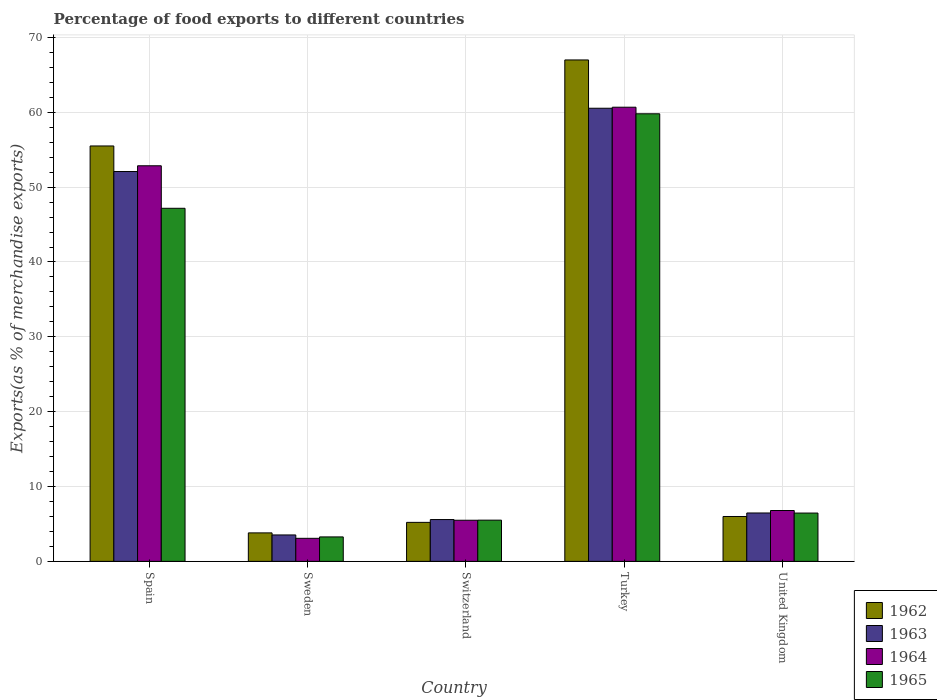How many groups of bars are there?
Your response must be concise. 5. Are the number of bars per tick equal to the number of legend labels?
Ensure brevity in your answer.  Yes. Are the number of bars on each tick of the X-axis equal?
Provide a succinct answer. Yes. How many bars are there on the 1st tick from the left?
Provide a short and direct response. 4. What is the label of the 4th group of bars from the left?
Your answer should be compact. Turkey. In how many cases, is the number of bars for a given country not equal to the number of legend labels?
Your answer should be compact. 0. What is the percentage of exports to different countries in 1963 in Sweden?
Provide a succinct answer. 3.53. Across all countries, what is the maximum percentage of exports to different countries in 1964?
Your response must be concise. 60.68. Across all countries, what is the minimum percentage of exports to different countries in 1963?
Offer a terse response. 3.53. In which country was the percentage of exports to different countries in 1964 maximum?
Make the answer very short. Turkey. In which country was the percentage of exports to different countries in 1965 minimum?
Your response must be concise. Sweden. What is the total percentage of exports to different countries in 1963 in the graph?
Offer a very short reply. 128.21. What is the difference between the percentage of exports to different countries in 1965 in Spain and that in Sweden?
Give a very brief answer. 43.9. What is the difference between the percentage of exports to different countries in 1963 in Turkey and the percentage of exports to different countries in 1962 in Spain?
Your answer should be compact. 5.04. What is the average percentage of exports to different countries in 1962 per country?
Keep it short and to the point. 27.5. What is the difference between the percentage of exports to different countries of/in 1963 and percentage of exports to different countries of/in 1964 in Spain?
Give a very brief answer. -0.77. In how many countries, is the percentage of exports to different countries in 1965 greater than 34 %?
Offer a terse response. 2. What is the ratio of the percentage of exports to different countries in 1964 in Sweden to that in United Kingdom?
Keep it short and to the point. 0.45. Is the percentage of exports to different countries in 1964 in Sweden less than that in Turkey?
Your answer should be compact. Yes. Is the difference between the percentage of exports to different countries in 1963 in Sweden and Switzerland greater than the difference between the percentage of exports to different countries in 1964 in Sweden and Switzerland?
Your response must be concise. Yes. What is the difference between the highest and the second highest percentage of exports to different countries in 1964?
Offer a terse response. 7.83. What is the difference between the highest and the lowest percentage of exports to different countries in 1965?
Give a very brief answer. 56.53. Is it the case that in every country, the sum of the percentage of exports to different countries in 1963 and percentage of exports to different countries in 1962 is greater than the sum of percentage of exports to different countries in 1964 and percentage of exports to different countries in 1965?
Offer a very short reply. No. What does the 4th bar from the right in Spain represents?
Your answer should be very brief. 1962. Is it the case that in every country, the sum of the percentage of exports to different countries in 1962 and percentage of exports to different countries in 1963 is greater than the percentage of exports to different countries in 1964?
Offer a terse response. Yes. How many bars are there?
Provide a short and direct response. 20. How many countries are there in the graph?
Your answer should be very brief. 5. What is the difference between two consecutive major ticks on the Y-axis?
Your answer should be compact. 10. Are the values on the major ticks of Y-axis written in scientific E-notation?
Provide a succinct answer. No. Does the graph contain grids?
Give a very brief answer. Yes. Where does the legend appear in the graph?
Offer a very short reply. Bottom right. How many legend labels are there?
Provide a succinct answer. 4. What is the title of the graph?
Keep it short and to the point. Percentage of food exports to different countries. Does "1984" appear as one of the legend labels in the graph?
Make the answer very short. No. What is the label or title of the X-axis?
Keep it short and to the point. Country. What is the label or title of the Y-axis?
Provide a short and direct response. Exports(as % of merchandise exports). What is the Exports(as % of merchandise exports) of 1962 in Spain?
Offer a terse response. 55.5. What is the Exports(as % of merchandise exports) of 1963 in Spain?
Keep it short and to the point. 52.09. What is the Exports(as % of merchandise exports) in 1964 in Spain?
Your response must be concise. 52.85. What is the Exports(as % of merchandise exports) of 1965 in Spain?
Your response must be concise. 47.17. What is the Exports(as % of merchandise exports) of 1962 in Sweden?
Provide a succinct answer. 3.8. What is the Exports(as % of merchandise exports) of 1963 in Sweden?
Ensure brevity in your answer.  3.53. What is the Exports(as % of merchandise exports) of 1964 in Sweden?
Provide a short and direct response. 3.08. What is the Exports(as % of merchandise exports) in 1965 in Sweden?
Your response must be concise. 3.27. What is the Exports(as % of merchandise exports) in 1962 in Switzerland?
Offer a very short reply. 5.21. What is the Exports(as % of merchandise exports) of 1963 in Switzerland?
Make the answer very short. 5.59. What is the Exports(as % of merchandise exports) in 1964 in Switzerland?
Offer a very short reply. 5.49. What is the Exports(as % of merchandise exports) in 1965 in Switzerland?
Your response must be concise. 5.51. What is the Exports(as % of merchandise exports) of 1962 in Turkey?
Your answer should be very brief. 66.99. What is the Exports(as % of merchandise exports) of 1963 in Turkey?
Give a very brief answer. 60.54. What is the Exports(as % of merchandise exports) of 1964 in Turkey?
Offer a terse response. 60.68. What is the Exports(as % of merchandise exports) in 1965 in Turkey?
Your response must be concise. 59.8. What is the Exports(as % of merchandise exports) in 1962 in United Kingdom?
Offer a terse response. 5.99. What is the Exports(as % of merchandise exports) of 1963 in United Kingdom?
Your answer should be compact. 6.47. What is the Exports(as % of merchandise exports) in 1964 in United Kingdom?
Offer a terse response. 6.79. What is the Exports(as % of merchandise exports) of 1965 in United Kingdom?
Keep it short and to the point. 6.45. Across all countries, what is the maximum Exports(as % of merchandise exports) of 1962?
Keep it short and to the point. 66.99. Across all countries, what is the maximum Exports(as % of merchandise exports) in 1963?
Your response must be concise. 60.54. Across all countries, what is the maximum Exports(as % of merchandise exports) of 1964?
Your answer should be compact. 60.68. Across all countries, what is the maximum Exports(as % of merchandise exports) of 1965?
Make the answer very short. 59.8. Across all countries, what is the minimum Exports(as % of merchandise exports) in 1962?
Your response must be concise. 3.8. Across all countries, what is the minimum Exports(as % of merchandise exports) in 1963?
Offer a terse response. 3.53. Across all countries, what is the minimum Exports(as % of merchandise exports) of 1964?
Your answer should be very brief. 3.08. Across all countries, what is the minimum Exports(as % of merchandise exports) in 1965?
Provide a succinct answer. 3.27. What is the total Exports(as % of merchandise exports) of 1962 in the graph?
Offer a terse response. 137.5. What is the total Exports(as % of merchandise exports) of 1963 in the graph?
Ensure brevity in your answer.  128.21. What is the total Exports(as % of merchandise exports) in 1964 in the graph?
Give a very brief answer. 128.9. What is the total Exports(as % of merchandise exports) in 1965 in the graph?
Ensure brevity in your answer.  122.2. What is the difference between the Exports(as % of merchandise exports) of 1962 in Spain and that in Sweden?
Provide a succinct answer. 51.7. What is the difference between the Exports(as % of merchandise exports) of 1963 in Spain and that in Sweden?
Provide a succinct answer. 48.56. What is the difference between the Exports(as % of merchandise exports) in 1964 in Spain and that in Sweden?
Provide a short and direct response. 49.77. What is the difference between the Exports(as % of merchandise exports) of 1965 in Spain and that in Sweden?
Ensure brevity in your answer.  43.9. What is the difference between the Exports(as % of merchandise exports) in 1962 in Spain and that in Switzerland?
Give a very brief answer. 50.29. What is the difference between the Exports(as % of merchandise exports) of 1963 in Spain and that in Switzerland?
Provide a short and direct response. 46.5. What is the difference between the Exports(as % of merchandise exports) in 1964 in Spain and that in Switzerland?
Your response must be concise. 47.36. What is the difference between the Exports(as % of merchandise exports) of 1965 in Spain and that in Switzerland?
Keep it short and to the point. 41.67. What is the difference between the Exports(as % of merchandise exports) of 1962 in Spain and that in Turkey?
Ensure brevity in your answer.  -11.49. What is the difference between the Exports(as % of merchandise exports) in 1963 in Spain and that in Turkey?
Offer a terse response. -8.46. What is the difference between the Exports(as % of merchandise exports) in 1964 in Spain and that in Turkey?
Ensure brevity in your answer.  -7.83. What is the difference between the Exports(as % of merchandise exports) in 1965 in Spain and that in Turkey?
Make the answer very short. -12.63. What is the difference between the Exports(as % of merchandise exports) in 1962 in Spain and that in United Kingdom?
Your response must be concise. 49.51. What is the difference between the Exports(as % of merchandise exports) in 1963 in Spain and that in United Kingdom?
Provide a short and direct response. 45.62. What is the difference between the Exports(as % of merchandise exports) of 1964 in Spain and that in United Kingdom?
Your response must be concise. 46.06. What is the difference between the Exports(as % of merchandise exports) in 1965 in Spain and that in United Kingdom?
Ensure brevity in your answer.  40.72. What is the difference between the Exports(as % of merchandise exports) in 1962 in Sweden and that in Switzerland?
Your answer should be compact. -1.4. What is the difference between the Exports(as % of merchandise exports) of 1963 in Sweden and that in Switzerland?
Provide a succinct answer. -2.06. What is the difference between the Exports(as % of merchandise exports) of 1964 in Sweden and that in Switzerland?
Your answer should be very brief. -2.41. What is the difference between the Exports(as % of merchandise exports) in 1965 in Sweden and that in Switzerland?
Ensure brevity in your answer.  -2.24. What is the difference between the Exports(as % of merchandise exports) in 1962 in Sweden and that in Turkey?
Offer a very short reply. -63.19. What is the difference between the Exports(as % of merchandise exports) of 1963 in Sweden and that in Turkey?
Your answer should be compact. -57.01. What is the difference between the Exports(as % of merchandise exports) in 1964 in Sweden and that in Turkey?
Make the answer very short. -57.6. What is the difference between the Exports(as % of merchandise exports) in 1965 in Sweden and that in Turkey?
Provide a succinct answer. -56.53. What is the difference between the Exports(as % of merchandise exports) in 1962 in Sweden and that in United Kingdom?
Your answer should be compact. -2.19. What is the difference between the Exports(as % of merchandise exports) of 1963 in Sweden and that in United Kingdom?
Your answer should be very brief. -2.94. What is the difference between the Exports(as % of merchandise exports) of 1964 in Sweden and that in United Kingdom?
Provide a short and direct response. -3.71. What is the difference between the Exports(as % of merchandise exports) in 1965 in Sweden and that in United Kingdom?
Offer a terse response. -3.19. What is the difference between the Exports(as % of merchandise exports) of 1962 in Switzerland and that in Turkey?
Your response must be concise. -61.78. What is the difference between the Exports(as % of merchandise exports) in 1963 in Switzerland and that in Turkey?
Offer a terse response. -54.96. What is the difference between the Exports(as % of merchandise exports) of 1964 in Switzerland and that in Turkey?
Your answer should be very brief. -55.18. What is the difference between the Exports(as % of merchandise exports) of 1965 in Switzerland and that in Turkey?
Offer a very short reply. -54.29. What is the difference between the Exports(as % of merchandise exports) of 1962 in Switzerland and that in United Kingdom?
Your answer should be very brief. -0.78. What is the difference between the Exports(as % of merchandise exports) of 1963 in Switzerland and that in United Kingdom?
Your answer should be very brief. -0.88. What is the difference between the Exports(as % of merchandise exports) in 1964 in Switzerland and that in United Kingdom?
Keep it short and to the point. -1.3. What is the difference between the Exports(as % of merchandise exports) of 1965 in Switzerland and that in United Kingdom?
Your answer should be compact. -0.95. What is the difference between the Exports(as % of merchandise exports) of 1962 in Turkey and that in United Kingdom?
Your response must be concise. 61. What is the difference between the Exports(as % of merchandise exports) of 1963 in Turkey and that in United Kingdom?
Provide a succinct answer. 54.08. What is the difference between the Exports(as % of merchandise exports) of 1964 in Turkey and that in United Kingdom?
Give a very brief answer. 53.88. What is the difference between the Exports(as % of merchandise exports) in 1965 in Turkey and that in United Kingdom?
Your answer should be very brief. 53.34. What is the difference between the Exports(as % of merchandise exports) in 1962 in Spain and the Exports(as % of merchandise exports) in 1963 in Sweden?
Provide a short and direct response. 51.97. What is the difference between the Exports(as % of merchandise exports) of 1962 in Spain and the Exports(as % of merchandise exports) of 1964 in Sweden?
Give a very brief answer. 52.42. What is the difference between the Exports(as % of merchandise exports) in 1962 in Spain and the Exports(as % of merchandise exports) in 1965 in Sweden?
Make the answer very short. 52.23. What is the difference between the Exports(as % of merchandise exports) in 1963 in Spain and the Exports(as % of merchandise exports) in 1964 in Sweden?
Your answer should be compact. 49.01. What is the difference between the Exports(as % of merchandise exports) of 1963 in Spain and the Exports(as % of merchandise exports) of 1965 in Sweden?
Your answer should be compact. 48.82. What is the difference between the Exports(as % of merchandise exports) of 1964 in Spain and the Exports(as % of merchandise exports) of 1965 in Sweden?
Offer a terse response. 49.58. What is the difference between the Exports(as % of merchandise exports) in 1962 in Spain and the Exports(as % of merchandise exports) in 1963 in Switzerland?
Make the answer very short. 49.92. What is the difference between the Exports(as % of merchandise exports) in 1962 in Spain and the Exports(as % of merchandise exports) in 1964 in Switzerland?
Provide a succinct answer. 50.01. What is the difference between the Exports(as % of merchandise exports) in 1962 in Spain and the Exports(as % of merchandise exports) in 1965 in Switzerland?
Your answer should be very brief. 49.99. What is the difference between the Exports(as % of merchandise exports) of 1963 in Spain and the Exports(as % of merchandise exports) of 1964 in Switzerland?
Keep it short and to the point. 46.59. What is the difference between the Exports(as % of merchandise exports) of 1963 in Spain and the Exports(as % of merchandise exports) of 1965 in Switzerland?
Your response must be concise. 46.58. What is the difference between the Exports(as % of merchandise exports) of 1964 in Spain and the Exports(as % of merchandise exports) of 1965 in Switzerland?
Offer a very short reply. 47.35. What is the difference between the Exports(as % of merchandise exports) of 1962 in Spain and the Exports(as % of merchandise exports) of 1963 in Turkey?
Your response must be concise. -5.04. What is the difference between the Exports(as % of merchandise exports) in 1962 in Spain and the Exports(as % of merchandise exports) in 1964 in Turkey?
Make the answer very short. -5.18. What is the difference between the Exports(as % of merchandise exports) in 1962 in Spain and the Exports(as % of merchandise exports) in 1965 in Turkey?
Your answer should be very brief. -4.3. What is the difference between the Exports(as % of merchandise exports) in 1963 in Spain and the Exports(as % of merchandise exports) in 1964 in Turkey?
Provide a short and direct response. -8.59. What is the difference between the Exports(as % of merchandise exports) of 1963 in Spain and the Exports(as % of merchandise exports) of 1965 in Turkey?
Your answer should be compact. -7.71. What is the difference between the Exports(as % of merchandise exports) in 1964 in Spain and the Exports(as % of merchandise exports) in 1965 in Turkey?
Ensure brevity in your answer.  -6.95. What is the difference between the Exports(as % of merchandise exports) of 1962 in Spain and the Exports(as % of merchandise exports) of 1963 in United Kingdom?
Ensure brevity in your answer.  49.04. What is the difference between the Exports(as % of merchandise exports) in 1962 in Spain and the Exports(as % of merchandise exports) in 1964 in United Kingdom?
Offer a very short reply. 48.71. What is the difference between the Exports(as % of merchandise exports) of 1962 in Spain and the Exports(as % of merchandise exports) of 1965 in United Kingdom?
Offer a terse response. 49.05. What is the difference between the Exports(as % of merchandise exports) in 1963 in Spain and the Exports(as % of merchandise exports) in 1964 in United Kingdom?
Your answer should be compact. 45.29. What is the difference between the Exports(as % of merchandise exports) in 1963 in Spain and the Exports(as % of merchandise exports) in 1965 in United Kingdom?
Provide a short and direct response. 45.63. What is the difference between the Exports(as % of merchandise exports) of 1964 in Spain and the Exports(as % of merchandise exports) of 1965 in United Kingdom?
Offer a very short reply. 46.4. What is the difference between the Exports(as % of merchandise exports) of 1962 in Sweden and the Exports(as % of merchandise exports) of 1963 in Switzerland?
Give a very brief answer. -1.78. What is the difference between the Exports(as % of merchandise exports) in 1962 in Sweden and the Exports(as % of merchandise exports) in 1964 in Switzerland?
Your response must be concise. -1.69. What is the difference between the Exports(as % of merchandise exports) in 1962 in Sweden and the Exports(as % of merchandise exports) in 1965 in Switzerland?
Your answer should be very brief. -1.7. What is the difference between the Exports(as % of merchandise exports) of 1963 in Sweden and the Exports(as % of merchandise exports) of 1964 in Switzerland?
Keep it short and to the point. -1.96. What is the difference between the Exports(as % of merchandise exports) of 1963 in Sweden and the Exports(as % of merchandise exports) of 1965 in Switzerland?
Give a very brief answer. -1.98. What is the difference between the Exports(as % of merchandise exports) in 1964 in Sweden and the Exports(as % of merchandise exports) in 1965 in Switzerland?
Keep it short and to the point. -2.43. What is the difference between the Exports(as % of merchandise exports) of 1962 in Sweden and the Exports(as % of merchandise exports) of 1963 in Turkey?
Provide a short and direct response. -56.74. What is the difference between the Exports(as % of merchandise exports) of 1962 in Sweden and the Exports(as % of merchandise exports) of 1964 in Turkey?
Offer a very short reply. -56.87. What is the difference between the Exports(as % of merchandise exports) of 1962 in Sweden and the Exports(as % of merchandise exports) of 1965 in Turkey?
Your answer should be very brief. -55.99. What is the difference between the Exports(as % of merchandise exports) of 1963 in Sweden and the Exports(as % of merchandise exports) of 1964 in Turkey?
Your answer should be compact. -57.15. What is the difference between the Exports(as % of merchandise exports) in 1963 in Sweden and the Exports(as % of merchandise exports) in 1965 in Turkey?
Make the answer very short. -56.27. What is the difference between the Exports(as % of merchandise exports) in 1964 in Sweden and the Exports(as % of merchandise exports) in 1965 in Turkey?
Offer a very short reply. -56.72. What is the difference between the Exports(as % of merchandise exports) in 1962 in Sweden and the Exports(as % of merchandise exports) in 1963 in United Kingdom?
Your response must be concise. -2.66. What is the difference between the Exports(as % of merchandise exports) of 1962 in Sweden and the Exports(as % of merchandise exports) of 1964 in United Kingdom?
Offer a very short reply. -2.99. What is the difference between the Exports(as % of merchandise exports) in 1962 in Sweden and the Exports(as % of merchandise exports) in 1965 in United Kingdom?
Your answer should be very brief. -2.65. What is the difference between the Exports(as % of merchandise exports) of 1963 in Sweden and the Exports(as % of merchandise exports) of 1964 in United Kingdom?
Keep it short and to the point. -3.26. What is the difference between the Exports(as % of merchandise exports) in 1963 in Sweden and the Exports(as % of merchandise exports) in 1965 in United Kingdom?
Provide a short and direct response. -2.93. What is the difference between the Exports(as % of merchandise exports) of 1964 in Sweden and the Exports(as % of merchandise exports) of 1965 in United Kingdom?
Your answer should be compact. -3.38. What is the difference between the Exports(as % of merchandise exports) of 1962 in Switzerland and the Exports(as % of merchandise exports) of 1963 in Turkey?
Keep it short and to the point. -55.33. What is the difference between the Exports(as % of merchandise exports) in 1962 in Switzerland and the Exports(as % of merchandise exports) in 1964 in Turkey?
Your response must be concise. -55.47. What is the difference between the Exports(as % of merchandise exports) in 1962 in Switzerland and the Exports(as % of merchandise exports) in 1965 in Turkey?
Ensure brevity in your answer.  -54.59. What is the difference between the Exports(as % of merchandise exports) in 1963 in Switzerland and the Exports(as % of merchandise exports) in 1964 in Turkey?
Your answer should be compact. -55.09. What is the difference between the Exports(as % of merchandise exports) of 1963 in Switzerland and the Exports(as % of merchandise exports) of 1965 in Turkey?
Provide a succinct answer. -54.21. What is the difference between the Exports(as % of merchandise exports) of 1964 in Switzerland and the Exports(as % of merchandise exports) of 1965 in Turkey?
Offer a terse response. -54.31. What is the difference between the Exports(as % of merchandise exports) of 1962 in Switzerland and the Exports(as % of merchandise exports) of 1963 in United Kingdom?
Give a very brief answer. -1.26. What is the difference between the Exports(as % of merchandise exports) in 1962 in Switzerland and the Exports(as % of merchandise exports) in 1964 in United Kingdom?
Offer a very short reply. -1.58. What is the difference between the Exports(as % of merchandise exports) of 1962 in Switzerland and the Exports(as % of merchandise exports) of 1965 in United Kingdom?
Offer a terse response. -1.25. What is the difference between the Exports(as % of merchandise exports) in 1963 in Switzerland and the Exports(as % of merchandise exports) in 1964 in United Kingdom?
Give a very brief answer. -1.21. What is the difference between the Exports(as % of merchandise exports) of 1963 in Switzerland and the Exports(as % of merchandise exports) of 1965 in United Kingdom?
Give a very brief answer. -0.87. What is the difference between the Exports(as % of merchandise exports) in 1964 in Switzerland and the Exports(as % of merchandise exports) in 1965 in United Kingdom?
Provide a short and direct response. -0.96. What is the difference between the Exports(as % of merchandise exports) in 1962 in Turkey and the Exports(as % of merchandise exports) in 1963 in United Kingdom?
Ensure brevity in your answer.  60.53. What is the difference between the Exports(as % of merchandise exports) of 1962 in Turkey and the Exports(as % of merchandise exports) of 1964 in United Kingdom?
Ensure brevity in your answer.  60.2. What is the difference between the Exports(as % of merchandise exports) of 1962 in Turkey and the Exports(as % of merchandise exports) of 1965 in United Kingdom?
Your answer should be very brief. 60.54. What is the difference between the Exports(as % of merchandise exports) in 1963 in Turkey and the Exports(as % of merchandise exports) in 1964 in United Kingdom?
Your answer should be very brief. 53.75. What is the difference between the Exports(as % of merchandise exports) in 1963 in Turkey and the Exports(as % of merchandise exports) in 1965 in United Kingdom?
Your answer should be very brief. 54.09. What is the difference between the Exports(as % of merchandise exports) of 1964 in Turkey and the Exports(as % of merchandise exports) of 1965 in United Kingdom?
Provide a succinct answer. 54.22. What is the average Exports(as % of merchandise exports) of 1962 per country?
Provide a short and direct response. 27.5. What is the average Exports(as % of merchandise exports) of 1963 per country?
Provide a short and direct response. 25.64. What is the average Exports(as % of merchandise exports) of 1964 per country?
Keep it short and to the point. 25.78. What is the average Exports(as % of merchandise exports) in 1965 per country?
Provide a succinct answer. 24.44. What is the difference between the Exports(as % of merchandise exports) in 1962 and Exports(as % of merchandise exports) in 1963 in Spain?
Your answer should be compact. 3.42. What is the difference between the Exports(as % of merchandise exports) of 1962 and Exports(as % of merchandise exports) of 1964 in Spain?
Offer a terse response. 2.65. What is the difference between the Exports(as % of merchandise exports) in 1962 and Exports(as % of merchandise exports) in 1965 in Spain?
Ensure brevity in your answer.  8.33. What is the difference between the Exports(as % of merchandise exports) in 1963 and Exports(as % of merchandise exports) in 1964 in Spain?
Provide a succinct answer. -0.77. What is the difference between the Exports(as % of merchandise exports) in 1963 and Exports(as % of merchandise exports) in 1965 in Spain?
Make the answer very short. 4.91. What is the difference between the Exports(as % of merchandise exports) of 1964 and Exports(as % of merchandise exports) of 1965 in Spain?
Offer a very short reply. 5.68. What is the difference between the Exports(as % of merchandise exports) in 1962 and Exports(as % of merchandise exports) in 1963 in Sweden?
Ensure brevity in your answer.  0.28. What is the difference between the Exports(as % of merchandise exports) in 1962 and Exports(as % of merchandise exports) in 1964 in Sweden?
Provide a short and direct response. 0.73. What is the difference between the Exports(as % of merchandise exports) in 1962 and Exports(as % of merchandise exports) in 1965 in Sweden?
Make the answer very short. 0.54. What is the difference between the Exports(as % of merchandise exports) of 1963 and Exports(as % of merchandise exports) of 1964 in Sweden?
Provide a succinct answer. 0.45. What is the difference between the Exports(as % of merchandise exports) of 1963 and Exports(as % of merchandise exports) of 1965 in Sweden?
Offer a very short reply. 0.26. What is the difference between the Exports(as % of merchandise exports) of 1964 and Exports(as % of merchandise exports) of 1965 in Sweden?
Provide a short and direct response. -0.19. What is the difference between the Exports(as % of merchandise exports) of 1962 and Exports(as % of merchandise exports) of 1963 in Switzerland?
Offer a very short reply. -0.38. What is the difference between the Exports(as % of merchandise exports) of 1962 and Exports(as % of merchandise exports) of 1964 in Switzerland?
Keep it short and to the point. -0.28. What is the difference between the Exports(as % of merchandise exports) in 1962 and Exports(as % of merchandise exports) in 1965 in Switzerland?
Give a very brief answer. -0.3. What is the difference between the Exports(as % of merchandise exports) in 1963 and Exports(as % of merchandise exports) in 1964 in Switzerland?
Provide a short and direct response. 0.09. What is the difference between the Exports(as % of merchandise exports) of 1963 and Exports(as % of merchandise exports) of 1965 in Switzerland?
Provide a succinct answer. 0.08. What is the difference between the Exports(as % of merchandise exports) in 1964 and Exports(as % of merchandise exports) in 1965 in Switzerland?
Your response must be concise. -0.01. What is the difference between the Exports(as % of merchandise exports) in 1962 and Exports(as % of merchandise exports) in 1963 in Turkey?
Your response must be concise. 6.45. What is the difference between the Exports(as % of merchandise exports) in 1962 and Exports(as % of merchandise exports) in 1964 in Turkey?
Provide a short and direct response. 6.31. What is the difference between the Exports(as % of merchandise exports) in 1962 and Exports(as % of merchandise exports) in 1965 in Turkey?
Keep it short and to the point. 7.19. What is the difference between the Exports(as % of merchandise exports) of 1963 and Exports(as % of merchandise exports) of 1964 in Turkey?
Make the answer very short. -0.14. What is the difference between the Exports(as % of merchandise exports) in 1963 and Exports(as % of merchandise exports) in 1965 in Turkey?
Keep it short and to the point. 0.74. What is the difference between the Exports(as % of merchandise exports) in 1964 and Exports(as % of merchandise exports) in 1965 in Turkey?
Your answer should be very brief. 0.88. What is the difference between the Exports(as % of merchandise exports) in 1962 and Exports(as % of merchandise exports) in 1963 in United Kingdom?
Make the answer very short. -0.47. What is the difference between the Exports(as % of merchandise exports) in 1962 and Exports(as % of merchandise exports) in 1964 in United Kingdom?
Your answer should be compact. -0.8. What is the difference between the Exports(as % of merchandise exports) in 1962 and Exports(as % of merchandise exports) in 1965 in United Kingdom?
Ensure brevity in your answer.  -0.46. What is the difference between the Exports(as % of merchandise exports) in 1963 and Exports(as % of merchandise exports) in 1964 in United Kingdom?
Keep it short and to the point. -0.33. What is the difference between the Exports(as % of merchandise exports) in 1963 and Exports(as % of merchandise exports) in 1965 in United Kingdom?
Your response must be concise. 0.01. What is the difference between the Exports(as % of merchandise exports) of 1964 and Exports(as % of merchandise exports) of 1965 in United Kingdom?
Offer a very short reply. 0.34. What is the ratio of the Exports(as % of merchandise exports) of 1962 in Spain to that in Sweden?
Give a very brief answer. 14.59. What is the ratio of the Exports(as % of merchandise exports) in 1963 in Spain to that in Sweden?
Make the answer very short. 14.76. What is the ratio of the Exports(as % of merchandise exports) in 1964 in Spain to that in Sweden?
Provide a short and direct response. 17.17. What is the ratio of the Exports(as % of merchandise exports) of 1965 in Spain to that in Sweden?
Offer a very short reply. 14.44. What is the ratio of the Exports(as % of merchandise exports) of 1962 in Spain to that in Switzerland?
Make the answer very short. 10.65. What is the ratio of the Exports(as % of merchandise exports) in 1963 in Spain to that in Switzerland?
Your answer should be very brief. 9.33. What is the ratio of the Exports(as % of merchandise exports) of 1964 in Spain to that in Switzerland?
Keep it short and to the point. 9.62. What is the ratio of the Exports(as % of merchandise exports) of 1965 in Spain to that in Switzerland?
Make the answer very short. 8.57. What is the ratio of the Exports(as % of merchandise exports) in 1962 in Spain to that in Turkey?
Give a very brief answer. 0.83. What is the ratio of the Exports(as % of merchandise exports) in 1963 in Spain to that in Turkey?
Keep it short and to the point. 0.86. What is the ratio of the Exports(as % of merchandise exports) of 1964 in Spain to that in Turkey?
Give a very brief answer. 0.87. What is the ratio of the Exports(as % of merchandise exports) of 1965 in Spain to that in Turkey?
Provide a succinct answer. 0.79. What is the ratio of the Exports(as % of merchandise exports) in 1962 in Spain to that in United Kingdom?
Ensure brevity in your answer.  9.26. What is the ratio of the Exports(as % of merchandise exports) of 1963 in Spain to that in United Kingdom?
Your answer should be very brief. 8.06. What is the ratio of the Exports(as % of merchandise exports) in 1964 in Spain to that in United Kingdom?
Your answer should be very brief. 7.78. What is the ratio of the Exports(as % of merchandise exports) of 1965 in Spain to that in United Kingdom?
Your answer should be very brief. 7.31. What is the ratio of the Exports(as % of merchandise exports) in 1962 in Sweden to that in Switzerland?
Your answer should be compact. 0.73. What is the ratio of the Exports(as % of merchandise exports) in 1963 in Sweden to that in Switzerland?
Your response must be concise. 0.63. What is the ratio of the Exports(as % of merchandise exports) of 1964 in Sweden to that in Switzerland?
Your answer should be very brief. 0.56. What is the ratio of the Exports(as % of merchandise exports) in 1965 in Sweden to that in Switzerland?
Your answer should be compact. 0.59. What is the ratio of the Exports(as % of merchandise exports) of 1962 in Sweden to that in Turkey?
Your response must be concise. 0.06. What is the ratio of the Exports(as % of merchandise exports) in 1963 in Sweden to that in Turkey?
Provide a succinct answer. 0.06. What is the ratio of the Exports(as % of merchandise exports) in 1964 in Sweden to that in Turkey?
Your answer should be compact. 0.05. What is the ratio of the Exports(as % of merchandise exports) of 1965 in Sweden to that in Turkey?
Provide a succinct answer. 0.05. What is the ratio of the Exports(as % of merchandise exports) of 1962 in Sweden to that in United Kingdom?
Offer a terse response. 0.63. What is the ratio of the Exports(as % of merchandise exports) in 1963 in Sweden to that in United Kingdom?
Make the answer very short. 0.55. What is the ratio of the Exports(as % of merchandise exports) in 1964 in Sweden to that in United Kingdom?
Offer a very short reply. 0.45. What is the ratio of the Exports(as % of merchandise exports) in 1965 in Sweden to that in United Kingdom?
Provide a succinct answer. 0.51. What is the ratio of the Exports(as % of merchandise exports) in 1962 in Switzerland to that in Turkey?
Your answer should be very brief. 0.08. What is the ratio of the Exports(as % of merchandise exports) in 1963 in Switzerland to that in Turkey?
Ensure brevity in your answer.  0.09. What is the ratio of the Exports(as % of merchandise exports) in 1964 in Switzerland to that in Turkey?
Offer a terse response. 0.09. What is the ratio of the Exports(as % of merchandise exports) of 1965 in Switzerland to that in Turkey?
Provide a succinct answer. 0.09. What is the ratio of the Exports(as % of merchandise exports) of 1962 in Switzerland to that in United Kingdom?
Keep it short and to the point. 0.87. What is the ratio of the Exports(as % of merchandise exports) of 1963 in Switzerland to that in United Kingdom?
Provide a succinct answer. 0.86. What is the ratio of the Exports(as % of merchandise exports) in 1964 in Switzerland to that in United Kingdom?
Your response must be concise. 0.81. What is the ratio of the Exports(as % of merchandise exports) of 1965 in Switzerland to that in United Kingdom?
Keep it short and to the point. 0.85. What is the ratio of the Exports(as % of merchandise exports) of 1962 in Turkey to that in United Kingdom?
Make the answer very short. 11.18. What is the ratio of the Exports(as % of merchandise exports) in 1963 in Turkey to that in United Kingdom?
Your answer should be compact. 9.36. What is the ratio of the Exports(as % of merchandise exports) of 1964 in Turkey to that in United Kingdom?
Provide a succinct answer. 8.93. What is the ratio of the Exports(as % of merchandise exports) in 1965 in Turkey to that in United Kingdom?
Provide a succinct answer. 9.26. What is the difference between the highest and the second highest Exports(as % of merchandise exports) in 1962?
Your response must be concise. 11.49. What is the difference between the highest and the second highest Exports(as % of merchandise exports) in 1963?
Provide a succinct answer. 8.46. What is the difference between the highest and the second highest Exports(as % of merchandise exports) of 1964?
Ensure brevity in your answer.  7.83. What is the difference between the highest and the second highest Exports(as % of merchandise exports) in 1965?
Give a very brief answer. 12.63. What is the difference between the highest and the lowest Exports(as % of merchandise exports) of 1962?
Your response must be concise. 63.19. What is the difference between the highest and the lowest Exports(as % of merchandise exports) of 1963?
Offer a very short reply. 57.01. What is the difference between the highest and the lowest Exports(as % of merchandise exports) in 1964?
Offer a very short reply. 57.6. What is the difference between the highest and the lowest Exports(as % of merchandise exports) of 1965?
Offer a very short reply. 56.53. 